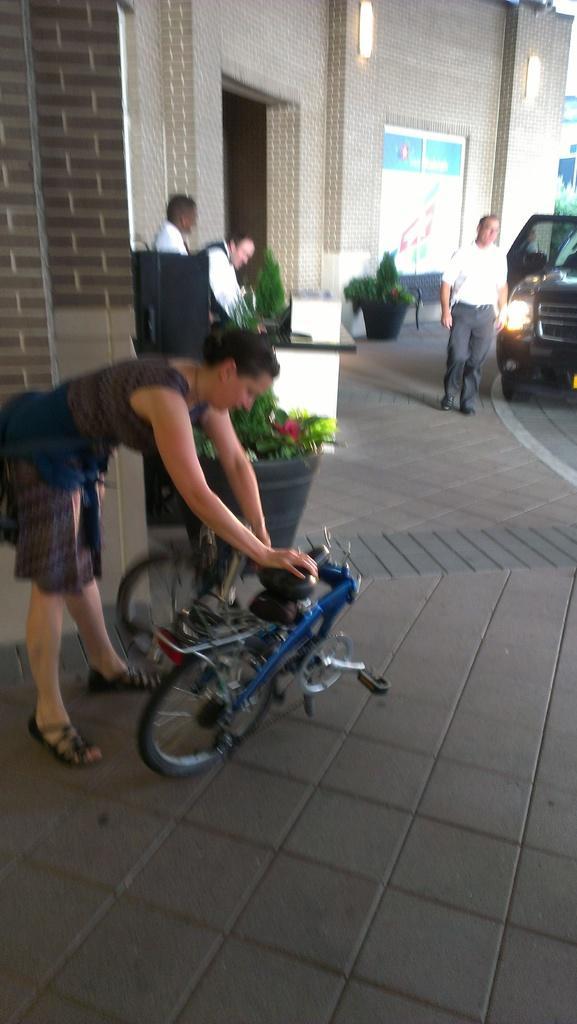Please provide a concise description of this image. This image is slightly blurred, where you can see this woman is standing here, we can see bicycles, flower pots, a few people standing here, we can see the car and the building in the background. 